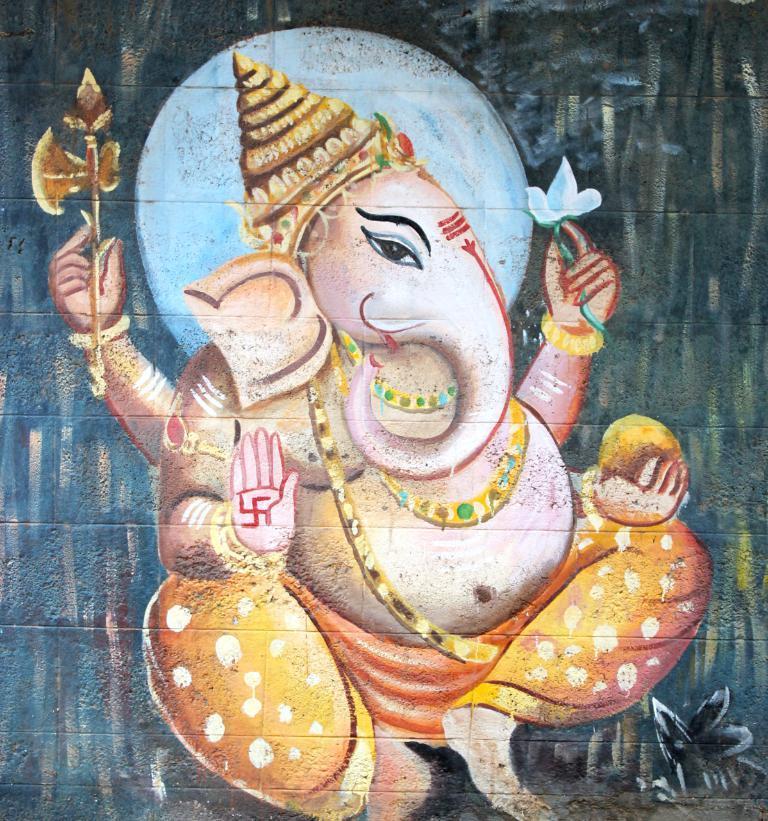How would you summarize this image in a sentence or two? There is a painting of an idol in the image. 